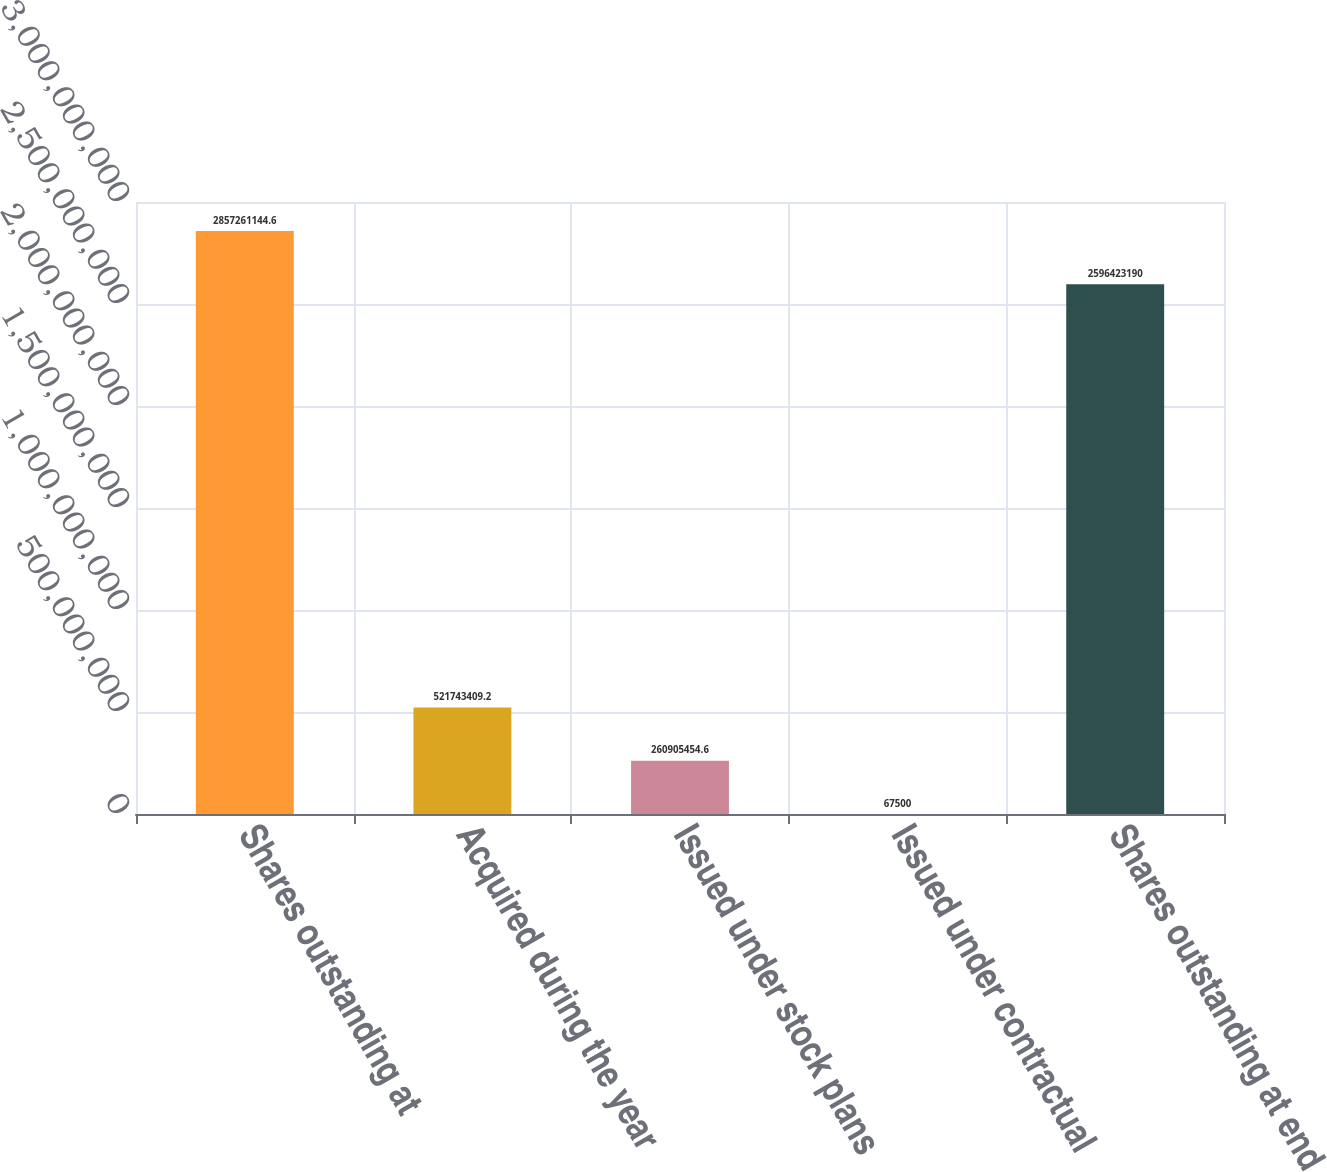Convert chart to OTSL. <chart><loc_0><loc_0><loc_500><loc_500><bar_chart><fcel>Shares outstanding at<fcel>Acquired during the year<fcel>Issued under stock plans<fcel>Issued under contractual<fcel>Shares outstanding at end of<nl><fcel>2.85726e+09<fcel>5.21743e+08<fcel>2.60905e+08<fcel>67500<fcel>2.59642e+09<nl></chart> 